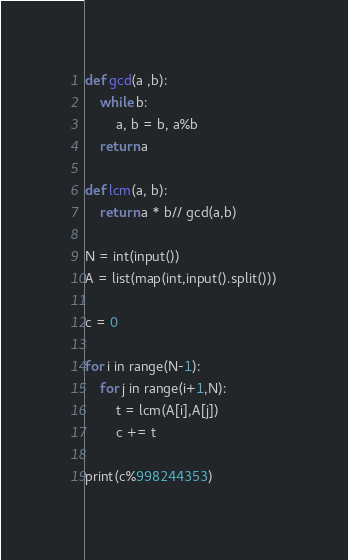<code> <loc_0><loc_0><loc_500><loc_500><_Python_>def gcd(a ,b):
    while b:
        a, b = b, a%b
    return a

def lcm(a, b):
    return a * b// gcd(a,b)

N = int(input())
A = list(map(int,input().split()))

c = 0

for i in range(N-1):
    for j in range(i+1,N):
        t = lcm(A[i],A[j])
        c += t

print(c%998244353)
</code> 